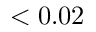<formula> <loc_0><loc_0><loc_500><loc_500>< 0 . 0 2</formula> 